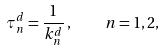<formula> <loc_0><loc_0><loc_500><loc_500>\tau _ { n } ^ { d } = \frac { 1 } { k _ { n } ^ { d } } \, , \quad n = 1 , 2 ,</formula> 